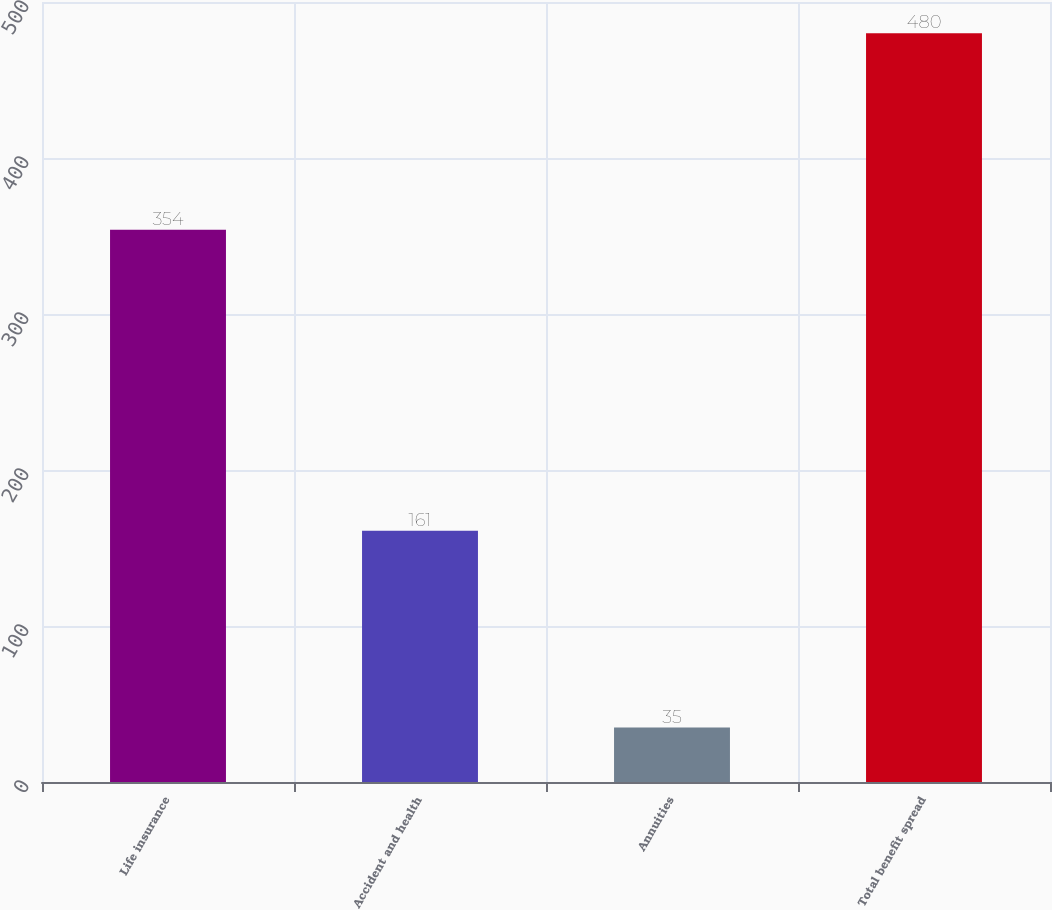Convert chart. <chart><loc_0><loc_0><loc_500><loc_500><bar_chart><fcel>Life insurance<fcel>Accident and health<fcel>Annuities<fcel>Total benefit spread<nl><fcel>354<fcel>161<fcel>35<fcel>480<nl></chart> 